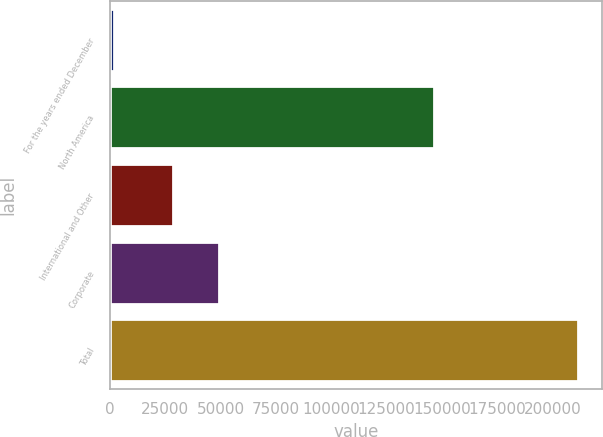Convert chart to OTSL. <chart><loc_0><loc_0><loc_500><loc_500><bar_chart><fcel>For the years ended December<fcel>North America<fcel>International and Other<fcel>Corporate<fcel>Total<nl><fcel>2014<fcel>146475<fcel>28463<fcel>49414.8<fcel>211532<nl></chart> 